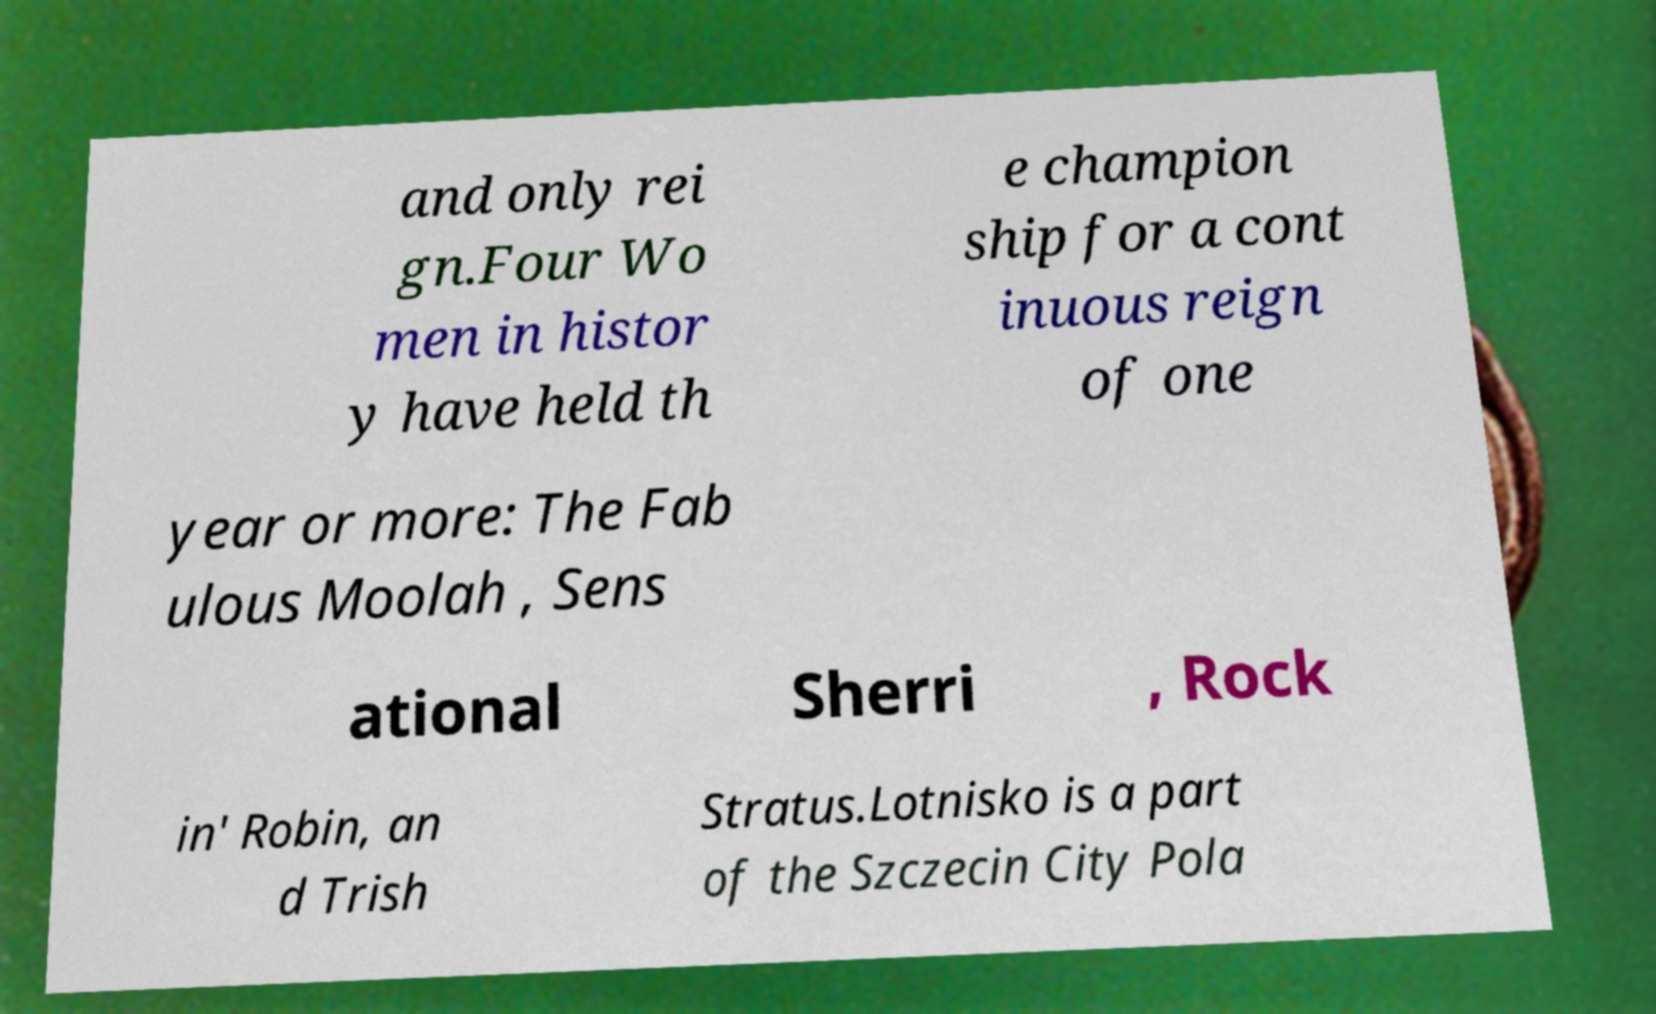Could you assist in decoding the text presented in this image and type it out clearly? and only rei gn.Four Wo men in histor y have held th e champion ship for a cont inuous reign of one year or more: The Fab ulous Moolah , Sens ational Sherri , Rock in' Robin, an d Trish Stratus.Lotnisko is a part of the Szczecin City Pola 